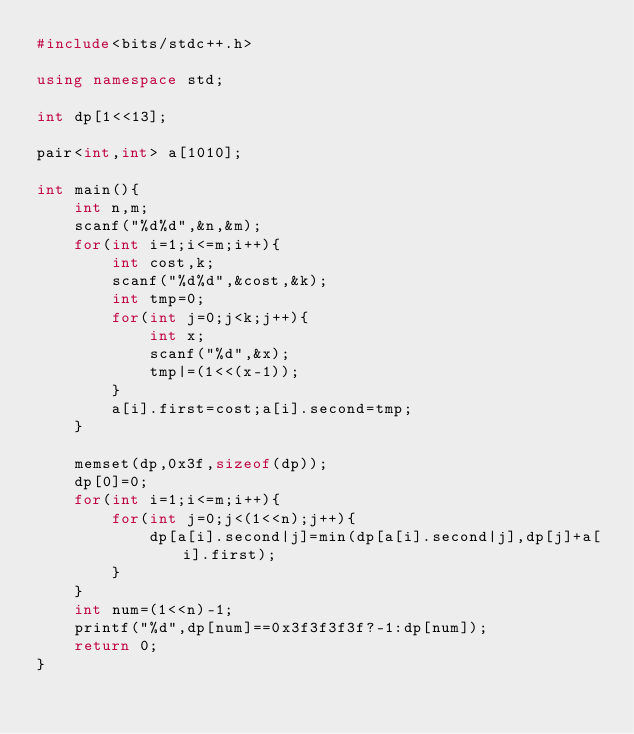<code> <loc_0><loc_0><loc_500><loc_500><_C++_>#include<bits/stdc++.h>

using namespace std;

int dp[1<<13];

pair<int,int> a[1010];

int main(){
	int n,m;
	scanf("%d%d",&n,&m);
	for(int i=1;i<=m;i++){
		int cost,k;
		scanf("%d%d",&cost,&k);
		int tmp=0;
		for(int j=0;j<k;j++){
			int x;
			scanf("%d",&x);
			tmp|=(1<<(x-1));
		}
		a[i].first=cost;a[i].second=tmp;
	}
	
	memset(dp,0x3f,sizeof(dp));
	dp[0]=0;
	for(int i=1;i<=m;i++){
		for(int j=0;j<(1<<n);j++){
			dp[a[i].second|j]=min(dp[a[i].second|j],dp[j]+a[i].first);
		}
	}
	int num=(1<<n)-1;
	printf("%d",dp[num]==0x3f3f3f3f?-1:dp[num]);
	return 0;
}</code> 